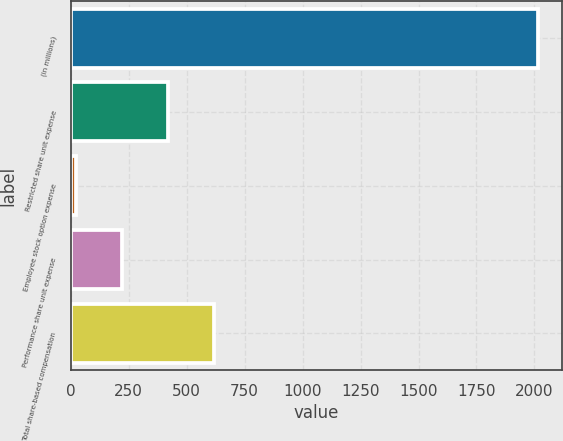<chart> <loc_0><loc_0><loc_500><loc_500><bar_chart><fcel>(in millions)<fcel>Restricted share unit expense<fcel>Employee stock option expense<fcel>Performance share unit expense<fcel>Total share-based compensation<nl><fcel>2016<fcel>420<fcel>21<fcel>220.5<fcel>619.5<nl></chart> 